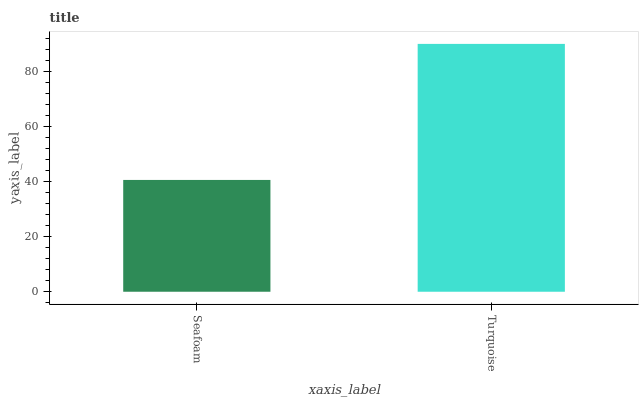Is Seafoam the minimum?
Answer yes or no. Yes. Is Turquoise the maximum?
Answer yes or no. Yes. Is Turquoise the minimum?
Answer yes or no. No. Is Turquoise greater than Seafoam?
Answer yes or no. Yes. Is Seafoam less than Turquoise?
Answer yes or no. Yes. Is Seafoam greater than Turquoise?
Answer yes or no. No. Is Turquoise less than Seafoam?
Answer yes or no. No. Is Turquoise the high median?
Answer yes or no. Yes. Is Seafoam the low median?
Answer yes or no. Yes. Is Seafoam the high median?
Answer yes or no. No. Is Turquoise the low median?
Answer yes or no. No. 